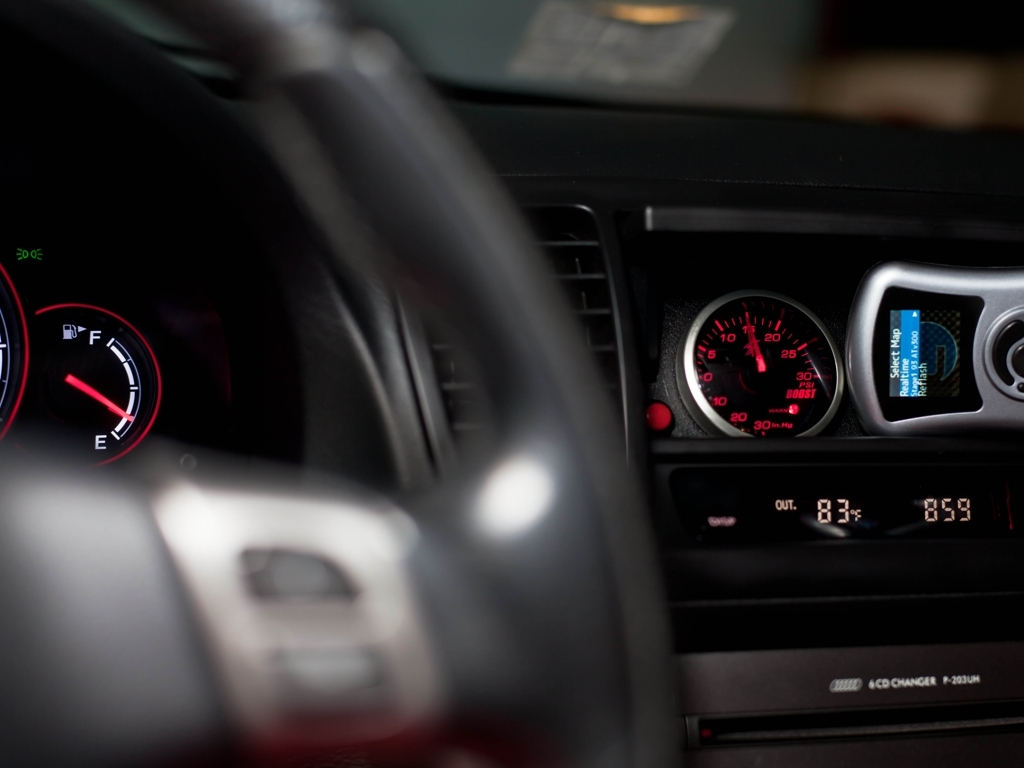How would you rate the quality of this image?
A. Relatively poor
B. Above average
C. Outstanding
Answer with the option's letter from the given choices directly. I would rate the quality of the image as 'A. Relatively poor'. The focus seems to be on the vehicle's dashboard, specifically the fuel gauge and speedometer, but the depth of field is shallow and doesn't allow the entire subject to be in clear view. Other components like the entertainment system are blurred out, and the image is slightly dark, hindering some detail recognition. 